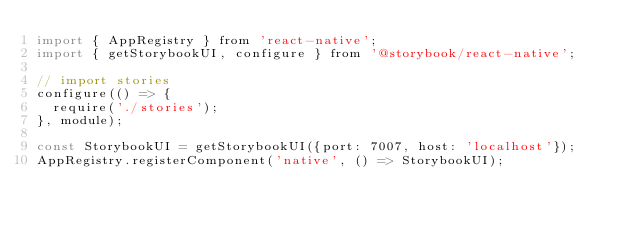Convert code to text. <code><loc_0><loc_0><loc_500><loc_500><_JavaScript_>import { AppRegistry } from 'react-native';
import { getStorybookUI, configure } from '@storybook/react-native';

// import stories
configure(() => {
  require('./stories');
}, module);

const StorybookUI = getStorybookUI({port: 7007, host: 'localhost'});
AppRegistry.registerComponent('native', () => StorybookUI);
</code> 